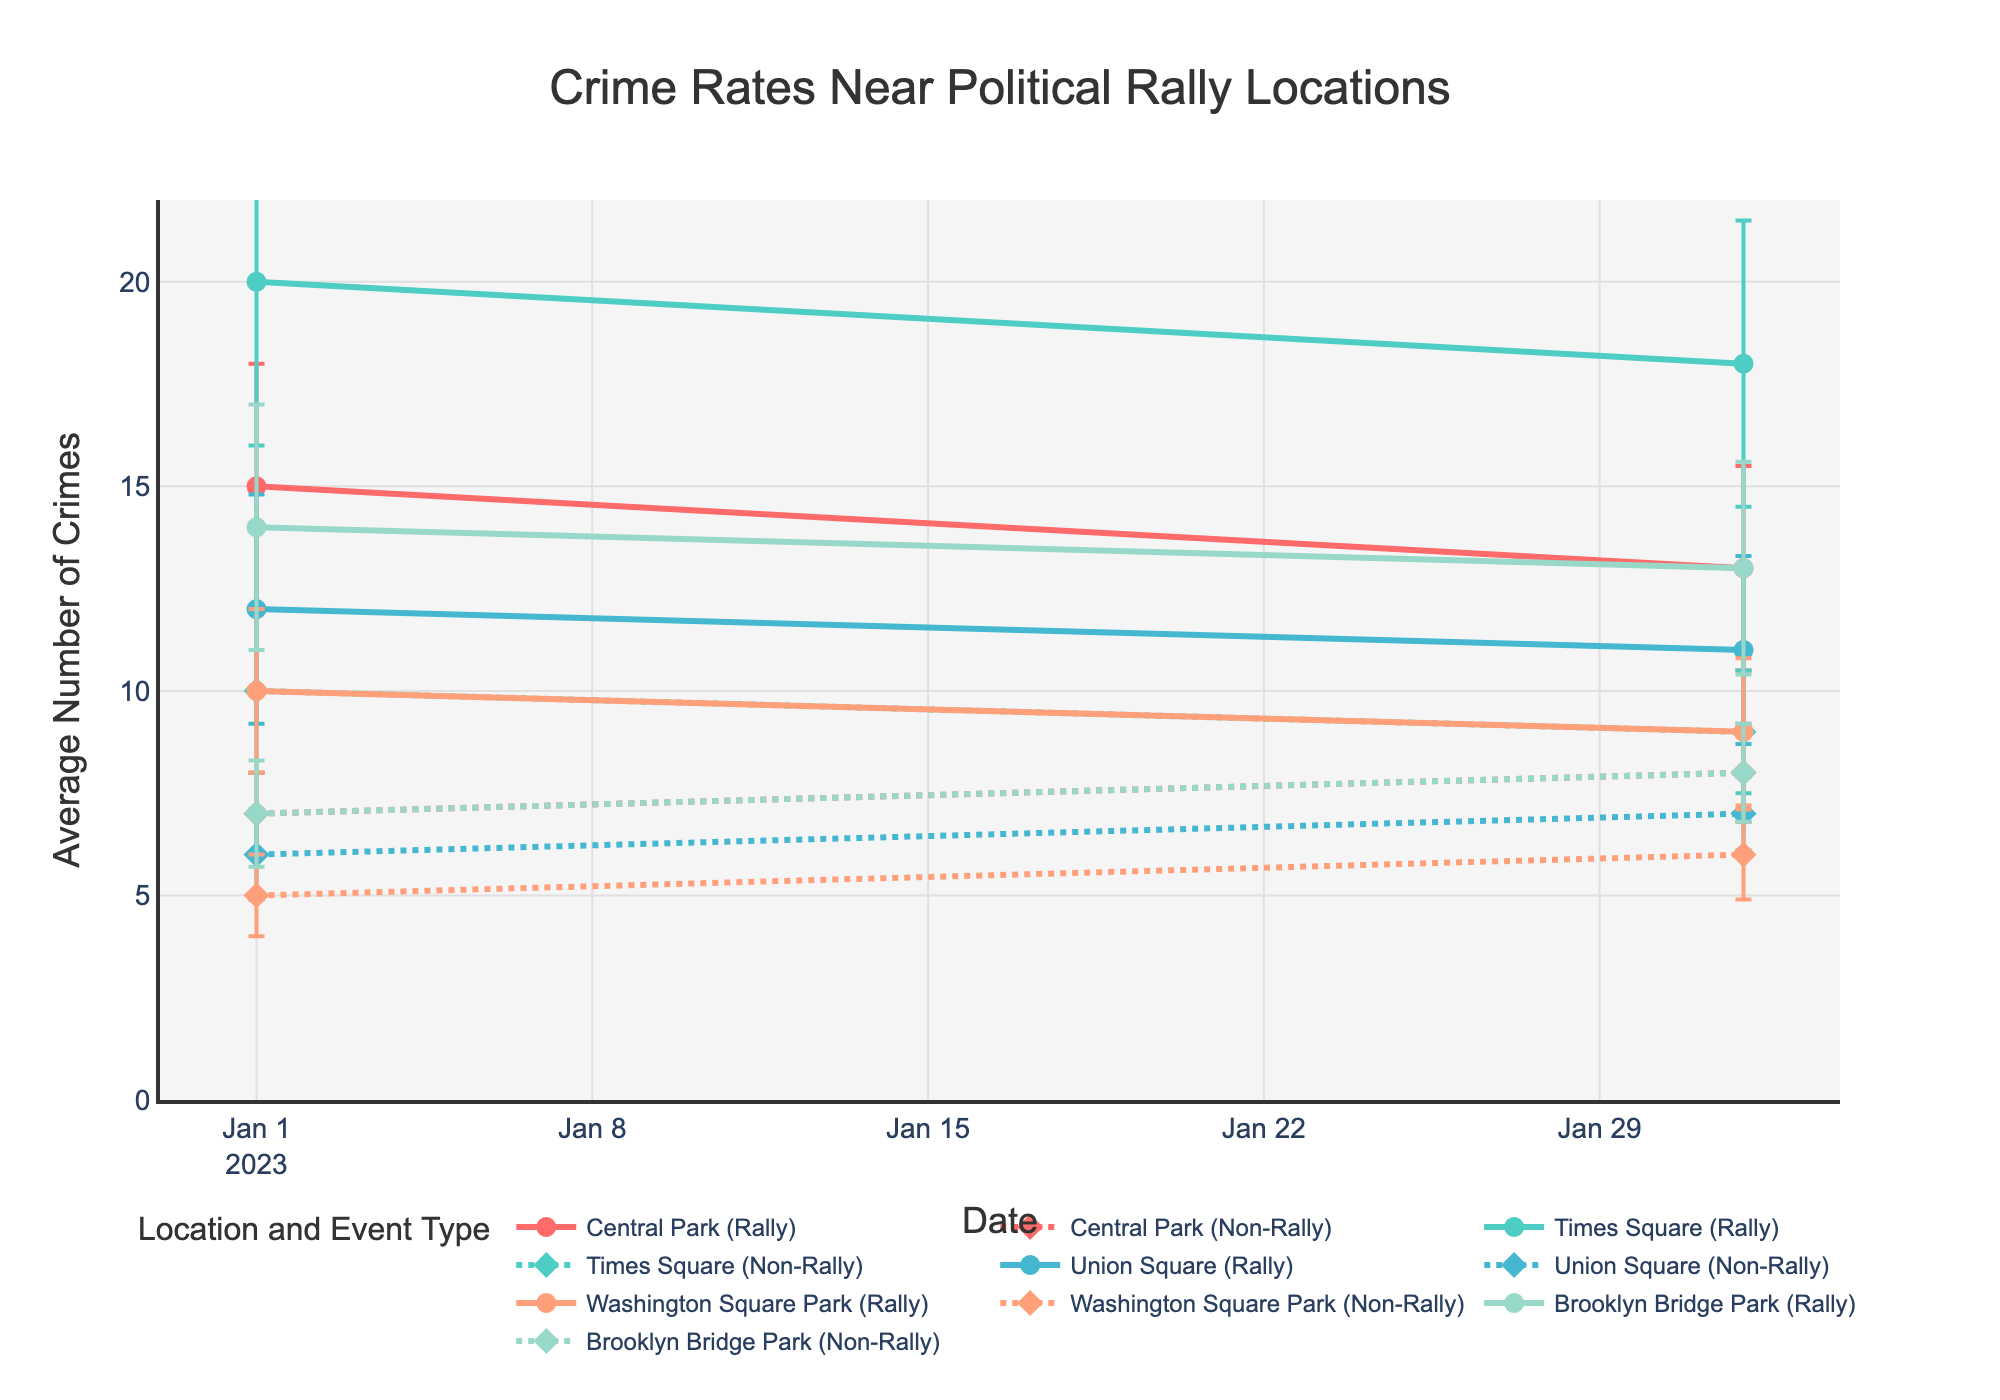What is the title of the plot? The title is typically displayed at the top of the plot. The title here is "Crime Rates Near Political Rally Locations".
Answer: Crime Rates Near Political Rally Locations How many locations are shown on the plot? The distinct locations can be identified by the different lines on the plot. There are five locations: Central Park, Times Square, Union Square, Washington Square Park, and Brooklyn Bridge Park.
Answer: Five Which location had the highest average number of crimes during rallies in January 2023? By looking at the lines and markers for January 2023, Times Square has a peak marker for crimes during rallies, which is 20.
Answer: Times Square What is the average number of crimes during rallies in Central Park in February 2023? Look for the line and marker representing Central Park in February 2023 for rallies. The marker shows an average of 13 crimes.
Answer: 13 Compare the average number of crimes during rallies and non-rallies in Brooklyn Bridge Park in January 2023. Which is higher? Identify the markers for Brooklyn Bridge Park in January 2023. During rallies, the average number of crimes is 14, while during non-rallies, it is 7. 14 is higher than 7.
Answer: During rallies For February 2023, which location showed the greatest reduction in crime rates from rally times to non-rally times? Calculate the difference between crimes during rallies and non-rallies for each location in February. For Central Park: 13-8=5, Times Square: 18-9=9, Union Square: 11-7=4, Washington Square Park: 9-6=3, Brooklyn Bridge Park: 13-8=5. Times Square has the greatest reduction of 9.
Answer: Times Square What is the sum of average crimes during rallies in all locations for January 2023? Add the average crimes during rallies for all locations in January 2023: Central Park (15), Times Square (20), Union Square (12), Washington Square Park (10), Brooklyn Bridge Park (14). Sum = 15+20+12+10+14 = 71.
Answer: 71 Is there a noticeable trend in crime rates during rallies across all locations from January to February 2023? Compare the lines for all locations from January to February. Most locations show a slight decrease in crimes from January to February during rally times.
Answer: Slight decrease Which location had the smallest confidence interval for non-rally crimes in February 2023? Check the error bars indicating confidence intervals for non-rally crimes in February 2023. Washington Square Park has the smallest interval with width 1.1.
Answer: Washington Square Park How do the average crime rates during rallies in January 2023 compare between Central Park and Times Square? Compare the markers for January 2023 for Central Park (15) and Times Square (20). Times Square has higher average crimes during rallies.
Answer: Times Square has higher average crimes 